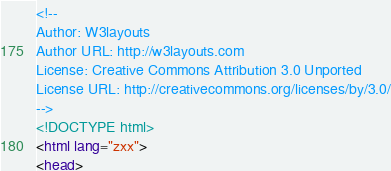Convert code to text. <code><loc_0><loc_0><loc_500><loc_500><_HTML_><!--
Author: W3layouts
Author URL: http://w3layouts.com
License: Creative Commons Attribution 3.0 Unported
License URL: http://creativecommons.org/licenses/by/3.0/
-->
<!DOCTYPE html>
<html lang="zxx">
<head></code> 